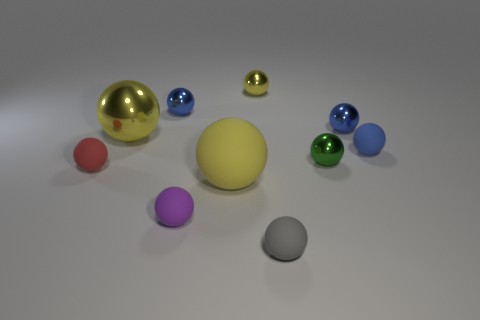Subtract all blue spheres. How many were subtracted if there are1blue spheres left? 2 Subtract 7 balls. How many balls are left? 3 Subtract all cyan cylinders. How many yellow balls are left? 3 Subtract all small red matte spheres. How many spheres are left? 9 Subtract all green balls. How many balls are left? 9 Subtract all purple balls. Subtract all green cubes. How many balls are left? 9 Add 9 large metallic balls. How many large metallic balls exist? 10 Subtract 0 brown cylinders. How many objects are left? 10 Subtract all metallic objects. Subtract all large matte spheres. How many objects are left? 4 Add 3 small yellow spheres. How many small yellow spheres are left? 4 